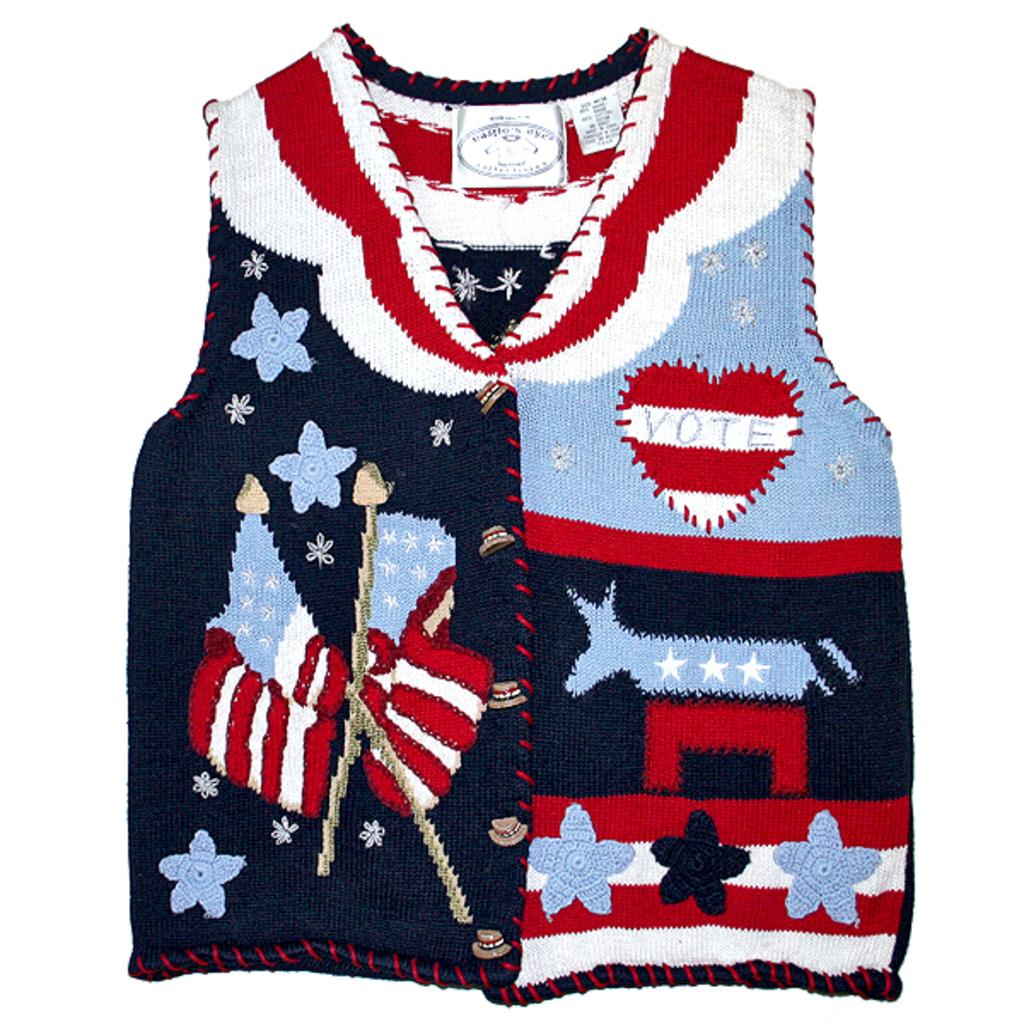What does the heart say?
Provide a short and direct response. Vote. 